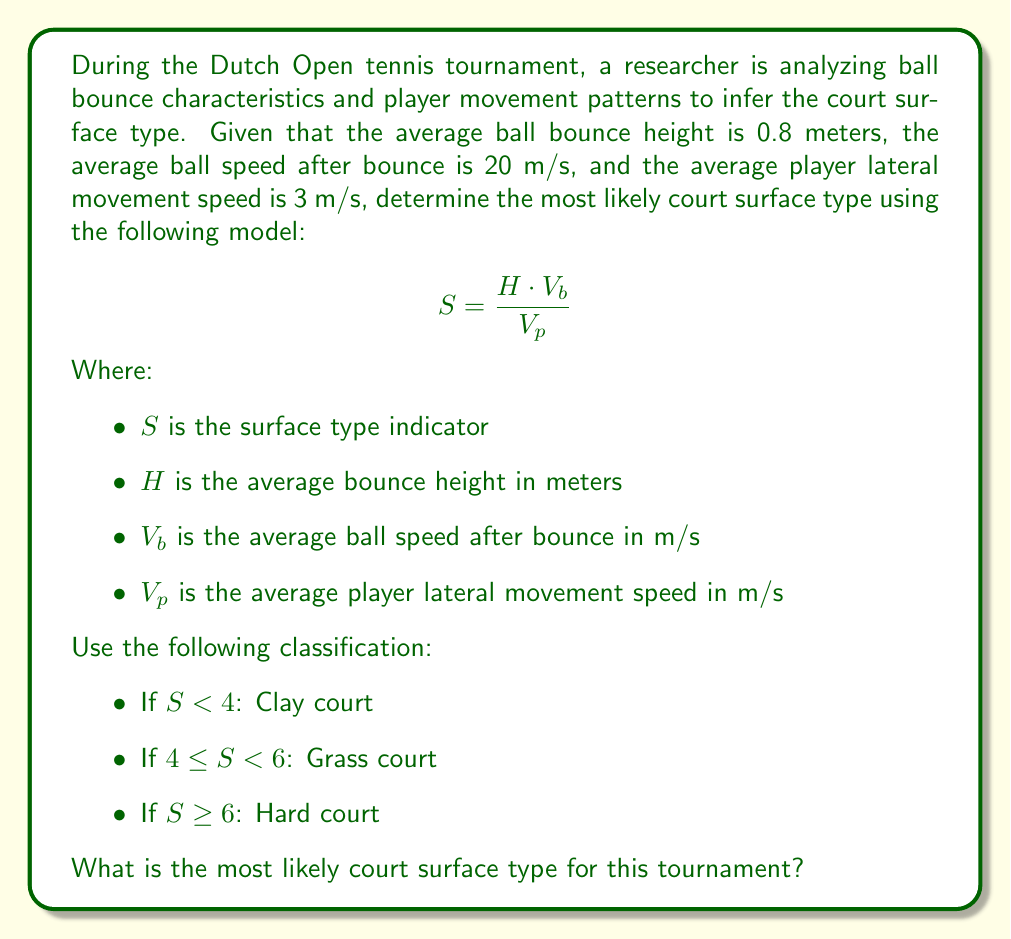Teach me how to tackle this problem. To solve this problem, we'll follow these steps:

1. Identify the given values:
   $H = 0.8$ meters (average bounce height)
   $V_b = 20$ m/s (average ball speed after bounce)
   $V_p = 3$ m/s (average player lateral movement speed)

2. Apply the given formula to calculate the surface type indicator $S$:

   $$ S = \frac{H \cdot V_b}{V_p} $$

3. Substitute the values:

   $$ S = \frac{0.8 \cdot 20}{3} $$

4. Perform the calculation:

   $$ S = \frac{16}{3} \approx 5.33 $$

5. Classify the result based on the given criteria:
   - If $S < 4$: Clay court
   - If $4 \leq S < 6$: Grass court
   - If $S \geq 6$: Hard court

   Since $5.33$ falls within the range $4 \leq S < 6$, the most likely court surface type is a grass court.

This result aligns with the characteristics of a grass court, which typically produces faster ball speeds and lower bounces compared to clay courts, but not as extreme as hard courts. The Dutch Open, while fictional in this context, could realistically be played on grass, similar to other European tournaments like Wimbledon.
Answer: Grass court 